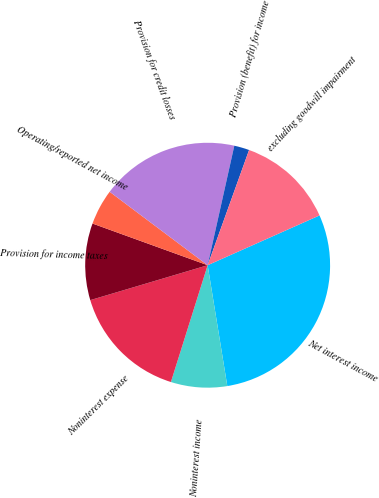Convert chart to OTSL. <chart><loc_0><loc_0><loc_500><loc_500><pie_chart><fcel>Net interest income<fcel>Noninterest income<fcel>Noninterest expense<fcel>Provision for income taxes<fcel>Operating/reported net income<fcel>Provision for credit losses<fcel>Provision (benefit) for income<fcel>excluding goodwill impairment<nl><fcel>29.1%<fcel>7.42%<fcel>15.55%<fcel>10.13%<fcel>4.71%<fcel>18.26%<fcel>2.0%<fcel>12.84%<nl></chart> 